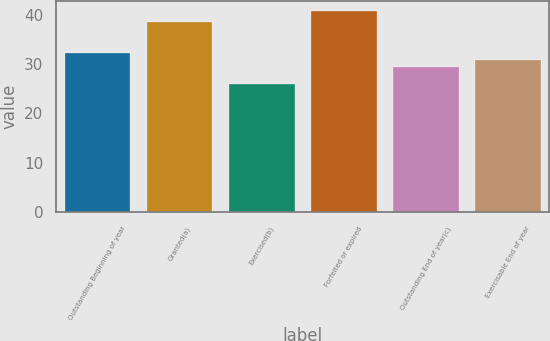Convert chart. <chart><loc_0><loc_0><loc_500><loc_500><bar_chart><fcel>Outstanding Beginning of year<fcel>Granted(a)<fcel>Exercised(b)<fcel>Forfeited or expired<fcel>Outstanding End of year(c)<fcel>Exercisable End of year<nl><fcel>32.29<fcel>38.47<fcel>25.96<fcel>40.75<fcel>29.33<fcel>30.81<nl></chart> 